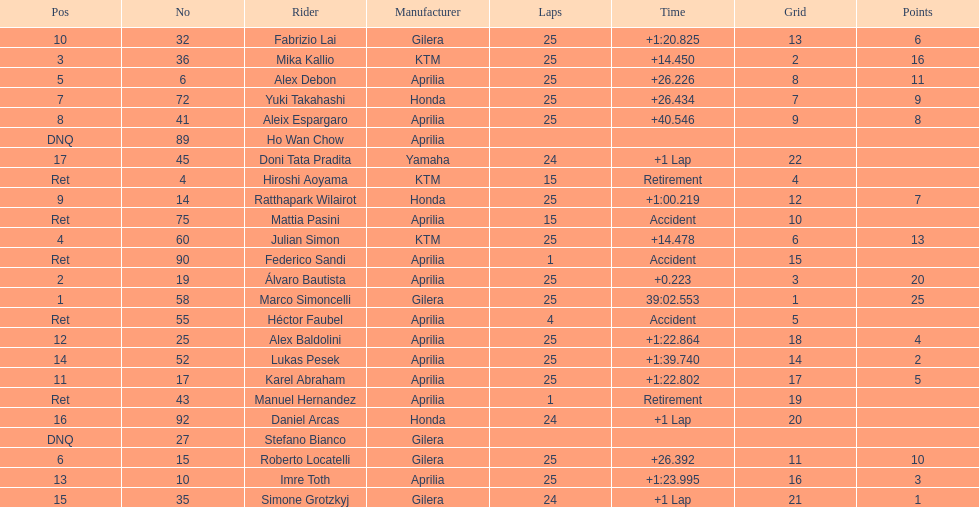What is the total number of rider? 24. 